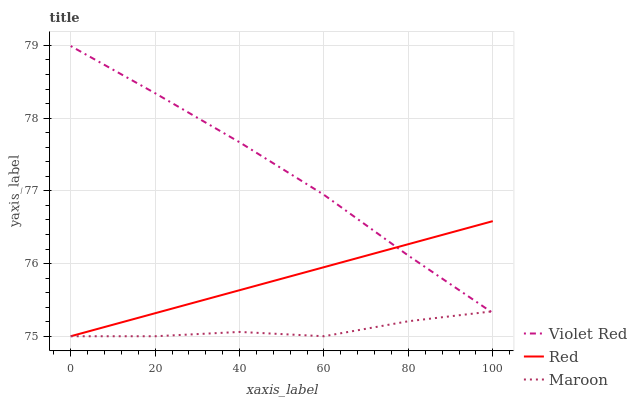Does Maroon have the minimum area under the curve?
Answer yes or no. Yes. Does Red have the minimum area under the curve?
Answer yes or no. No. Does Red have the maximum area under the curve?
Answer yes or no. No. Is Maroon the smoothest?
Answer yes or no. No. Is Red the roughest?
Answer yes or no. No. Does Red have the highest value?
Answer yes or no. No. 